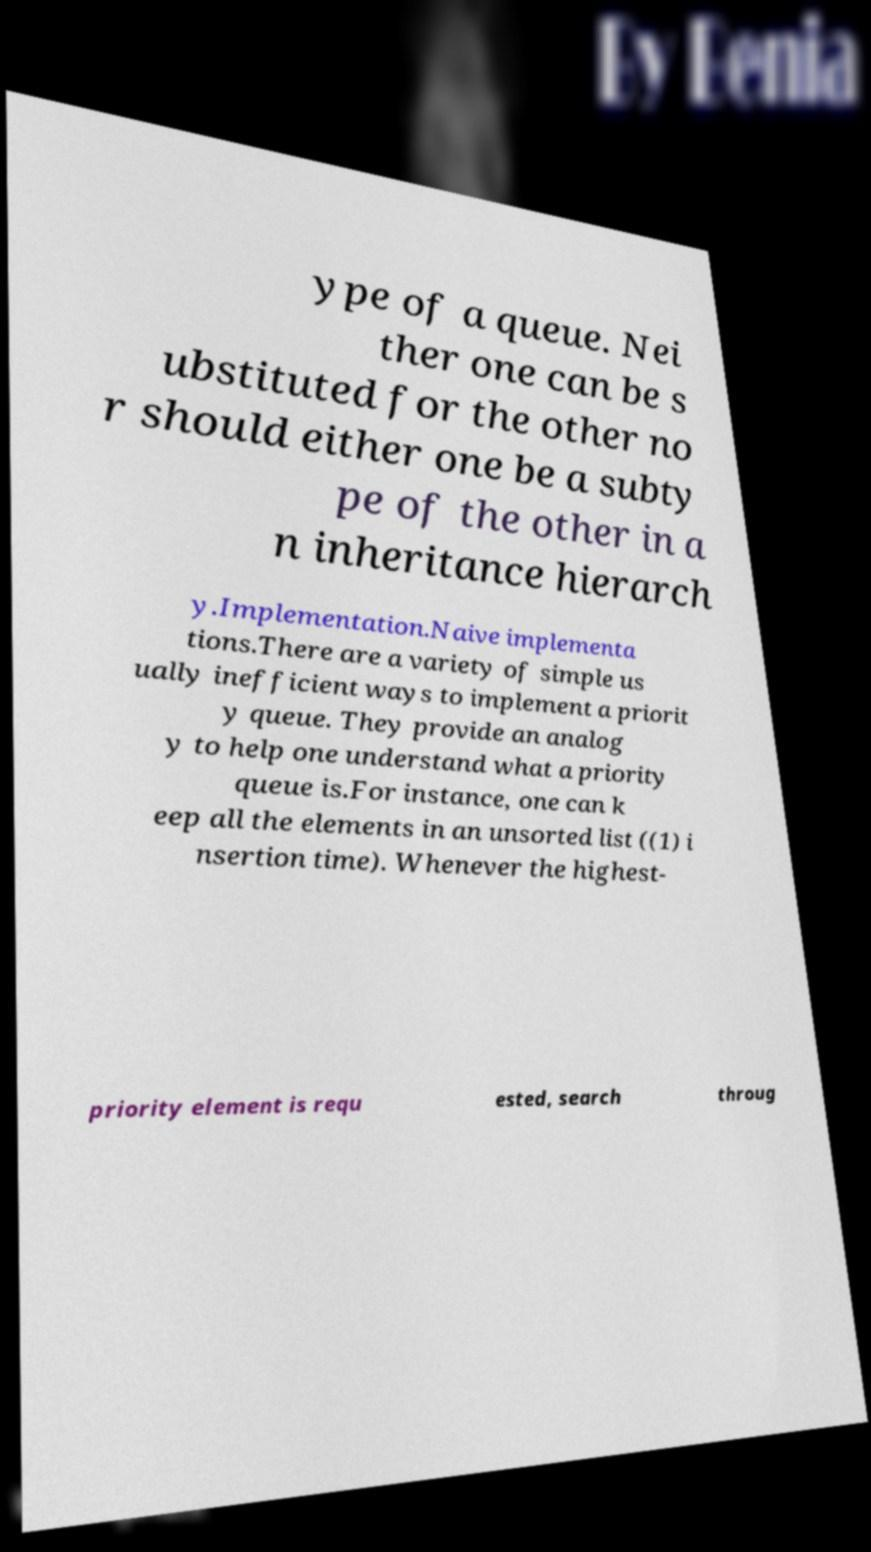Please identify and transcribe the text found in this image. ype of a queue. Nei ther one can be s ubstituted for the other no r should either one be a subty pe of the other in a n inheritance hierarch y.Implementation.Naive implementa tions.There are a variety of simple us ually inefficient ways to implement a priorit y queue. They provide an analog y to help one understand what a priority queue is.For instance, one can k eep all the elements in an unsorted list ((1) i nsertion time). Whenever the highest- priority element is requ ested, search throug 